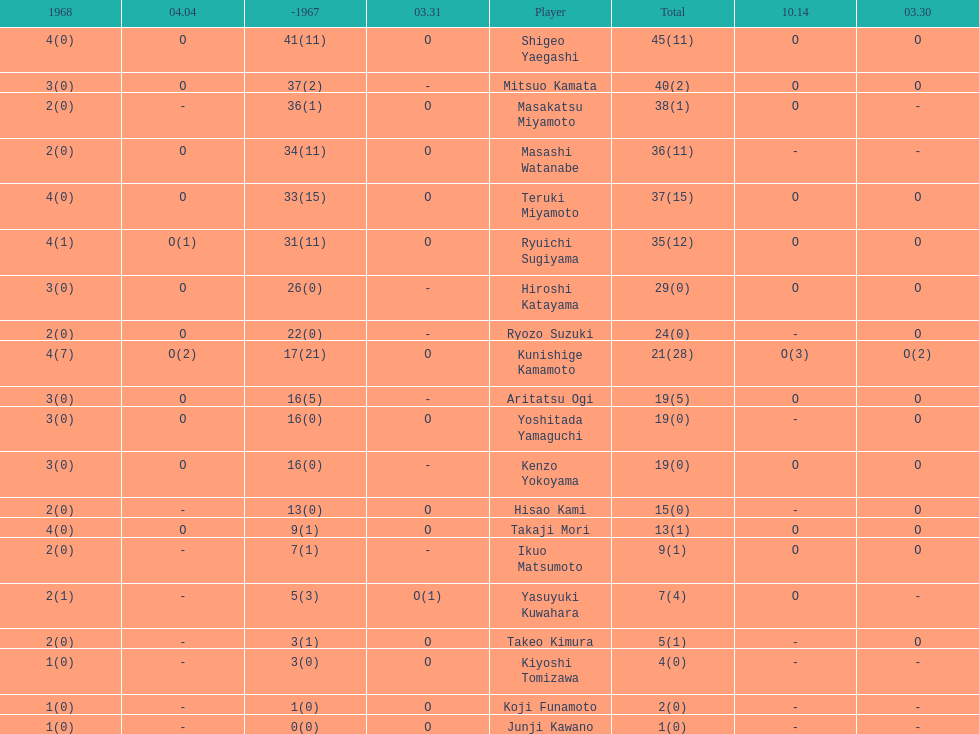Did mitsuo kamata have more than 40 total points? No. I'm looking to parse the entire table for insights. Could you assist me with that? {'header': ['1968', '04.04', '-1967', '03.31', 'Player', 'Total', '10.14', '03.30'], 'rows': [['4(0)', 'O', '41(11)', 'O', 'Shigeo Yaegashi', '45(11)', 'O', 'O'], ['3(0)', 'O', '37(2)', '-', 'Mitsuo Kamata', '40(2)', 'O', 'O'], ['2(0)', '-', '36(1)', 'O', 'Masakatsu Miyamoto', '38(1)', 'O', '-'], ['2(0)', 'O', '34(11)', 'O', 'Masashi Watanabe', '36(11)', '-', '-'], ['4(0)', 'O', '33(15)', 'O', 'Teruki Miyamoto', '37(15)', 'O', 'O'], ['4(1)', 'O(1)', '31(11)', 'O', 'Ryuichi Sugiyama', '35(12)', 'O', 'O'], ['3(0)', 'O', '26(0)', '-', 'Hiroshi Katayama', '29(0)', 'O', 'O'], ['2(0)', 'O', '22(0)', '-', 'Ryozo Suzuki', '24(0)', '-', 'O'], ['4(7)', 'O(2)', '17(21)', 'O', 'Kunishige Kamamoto', '21(28)', 'O(3)', 'O(2)'], ['3(0)', 'O', '16(5)', '-', 'Aritatsu Ogi', '19(5)', 'O', 'O'], ['3(0)', 'O', '16(0)', 'O', 'Yoshitada Yamaguchi', '19(0)', '-', 'O'], ['3(0)', 'O', '16(0)', '-', 'Kenzo Yokoyama', '19(0)', 'O', 'O'], ['2(0)', '-', '13(0)', 'O', 'Hisao Kami', '15(0)', '-', 'O'], ['4(0)', 'O', '9(1)', 'O', 'Takaji Mori', '13(1)', 'O', 'O'], ['2(0)', '-', '7(1)', '-', 'Ikuo Matsumoto', '9(1)', 'O', 'O'], ['2(1)', '-', '5(3)', 'O(1)', 'Yasuyuki Kuwahara', '7(4)', 'O', '-'], ['2(0)', '-', '3(1)', 'O', 'Takeo Kimura', '5(1)', '-', 'O'], ['1(0)', '-', '3(0)', 'O', 'Kiyoshi Tomizawa', '4(0)', '-', '-'], ['1(0)', '-', '1(0)', 'O', 'Koji Funamoto', '2(0)', '-', '-'], ['1(0)', '-', '0(0)', 'O', 'Junji Kawano', '1(0)', '-', '-']]} 